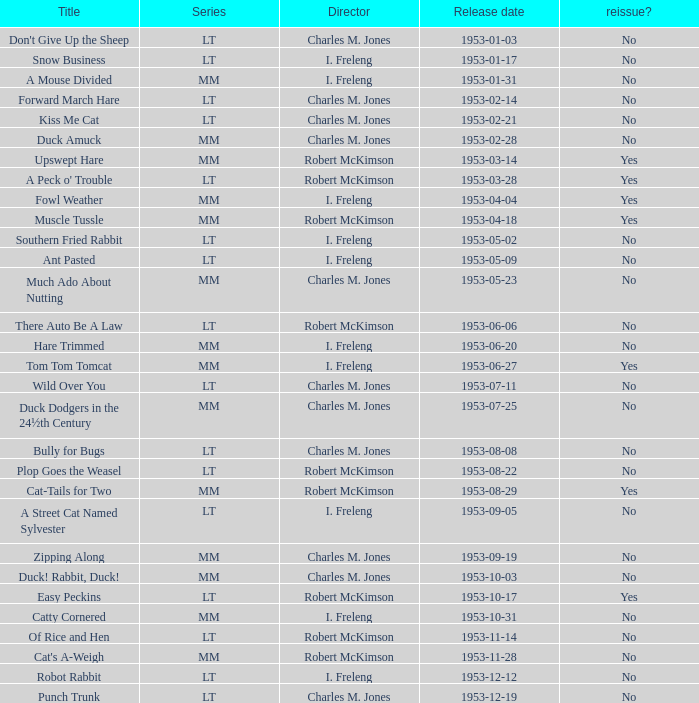On october 3, 1953, was there a new release of the film? No. 